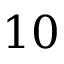Convert formula to latex. <formula><loc_0><loc_0><loc_500><loc_500>1 0</formula> 